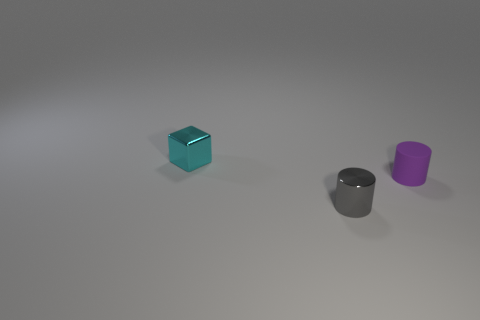Add 2 small gray objects. How many objects exist? 5 Subtract all cubes. How many objects are left? 2 Subtract all large green rubber spheres. Subtract all metallic objects. How many objects are left? 1 Add 3 small shiny cubes. How many small shiny cubes are left? 4 Add 3 big yellow shiny blocks. How many big yellow shiny blocks exist? 3 Subtract 0 green cylinders. How many objects are left? 3 